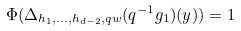<formula> <loc_0><loc_0><loc_500><loc_500>\Phi ( \Delta _ { h _ { 1 } , \dots , h _ { d - 2 } , q w } ( q ^ { - 1 } g _ { 1 } ) ( y ) ) = 1</formula> 